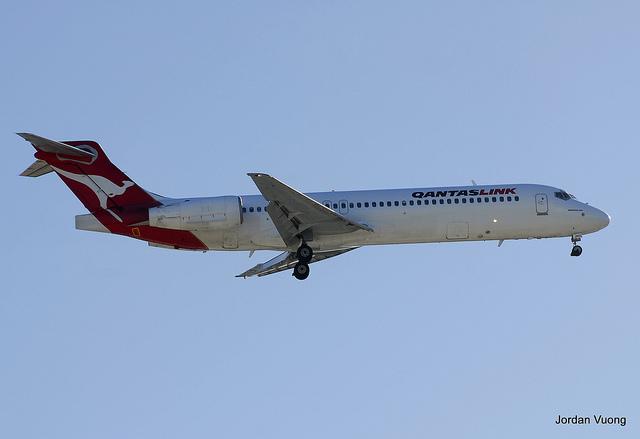Are cloud visible?
Short answer required. No. Is it daytime?
Concise answer only. Yes. Is this a commercial passenger plane?
Quick response, please. Yes. Is the plane completely horizontal?
Give a very brief answer. Yes. Is this a private plane?
Be succinct. No. 